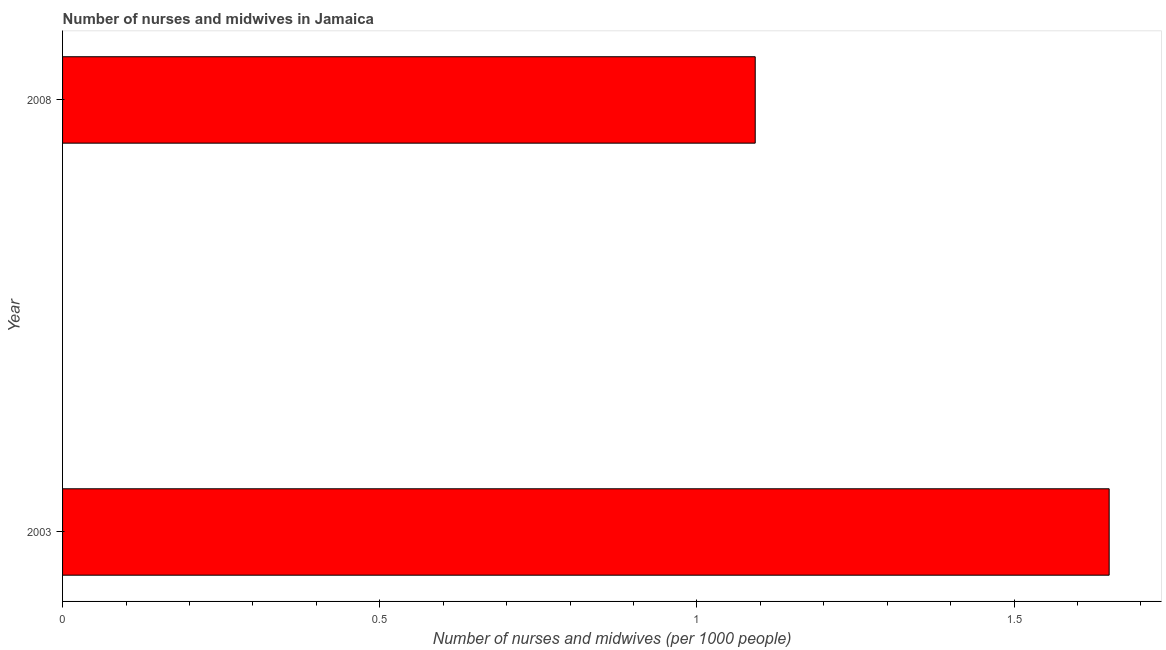Does the graph contain any zero values?
Keep it short and to the point. No. Does the graph contain grids?
Make the answer very short. No. What is the title of the graph?
Your response must be concise. Number of nurses and midwives in Jamaica. What is the label or title of the X-axis?
Your answer should be very brief. Number of nurses and midwives (per 1000 people). What is the label or title of the Y-axis?
Provide a succinct answer. Year. What is the number of nurses and midwives in 2003?
Keep it short and to the point. 1.65. Across all years, what is the maximum number of nurses and midwives?
Provide a succinct answer. 1.65. Across all years, what is the minimum number of nurses and midwives?
Offer a terse response. 1.09. What is the sum of the number of nurses and midwives?
Offer a terse response. 2.74. What is the difference between the number of nurses and midwives in 2003 and 2008?
Offer a very short reply. 0.56. What is the average number of nurses and midwives per year?
Provide a short and direct response. 1.37. What is the median number of nurses and midwives?
Offer a very short reply. 1.37. In how many years, is the number of nurses and midwives greater than 0.2 ?
Offer a very short reply. 2. What is the ratio of the number of nurses and midwives in 2003 to that in 2008?
Offer a terse response. 1.51. How many bars are there?
Offer a very short reply. 2. Are the values on the major ticks of X-axis written in scientific E-notation?
Offer a terse response. No. What is the Number of nurses and midwives (per 1000 people) of 2003?
Provide a succinct answer. 1.65. What is the Number of nurses and midwives (per 1000 people) in 2008?
Offer a very short reply. 1.09. What is the difference between the Number of nurses and midwives (per 1000 people) in 2003 and 2008?
Your answer should be compact. 0.56. What is the ratio of the Number of nurses and midwives (per 1000 people) in 2003 to that in 2008?
Your answer should be compact. 1.51. 